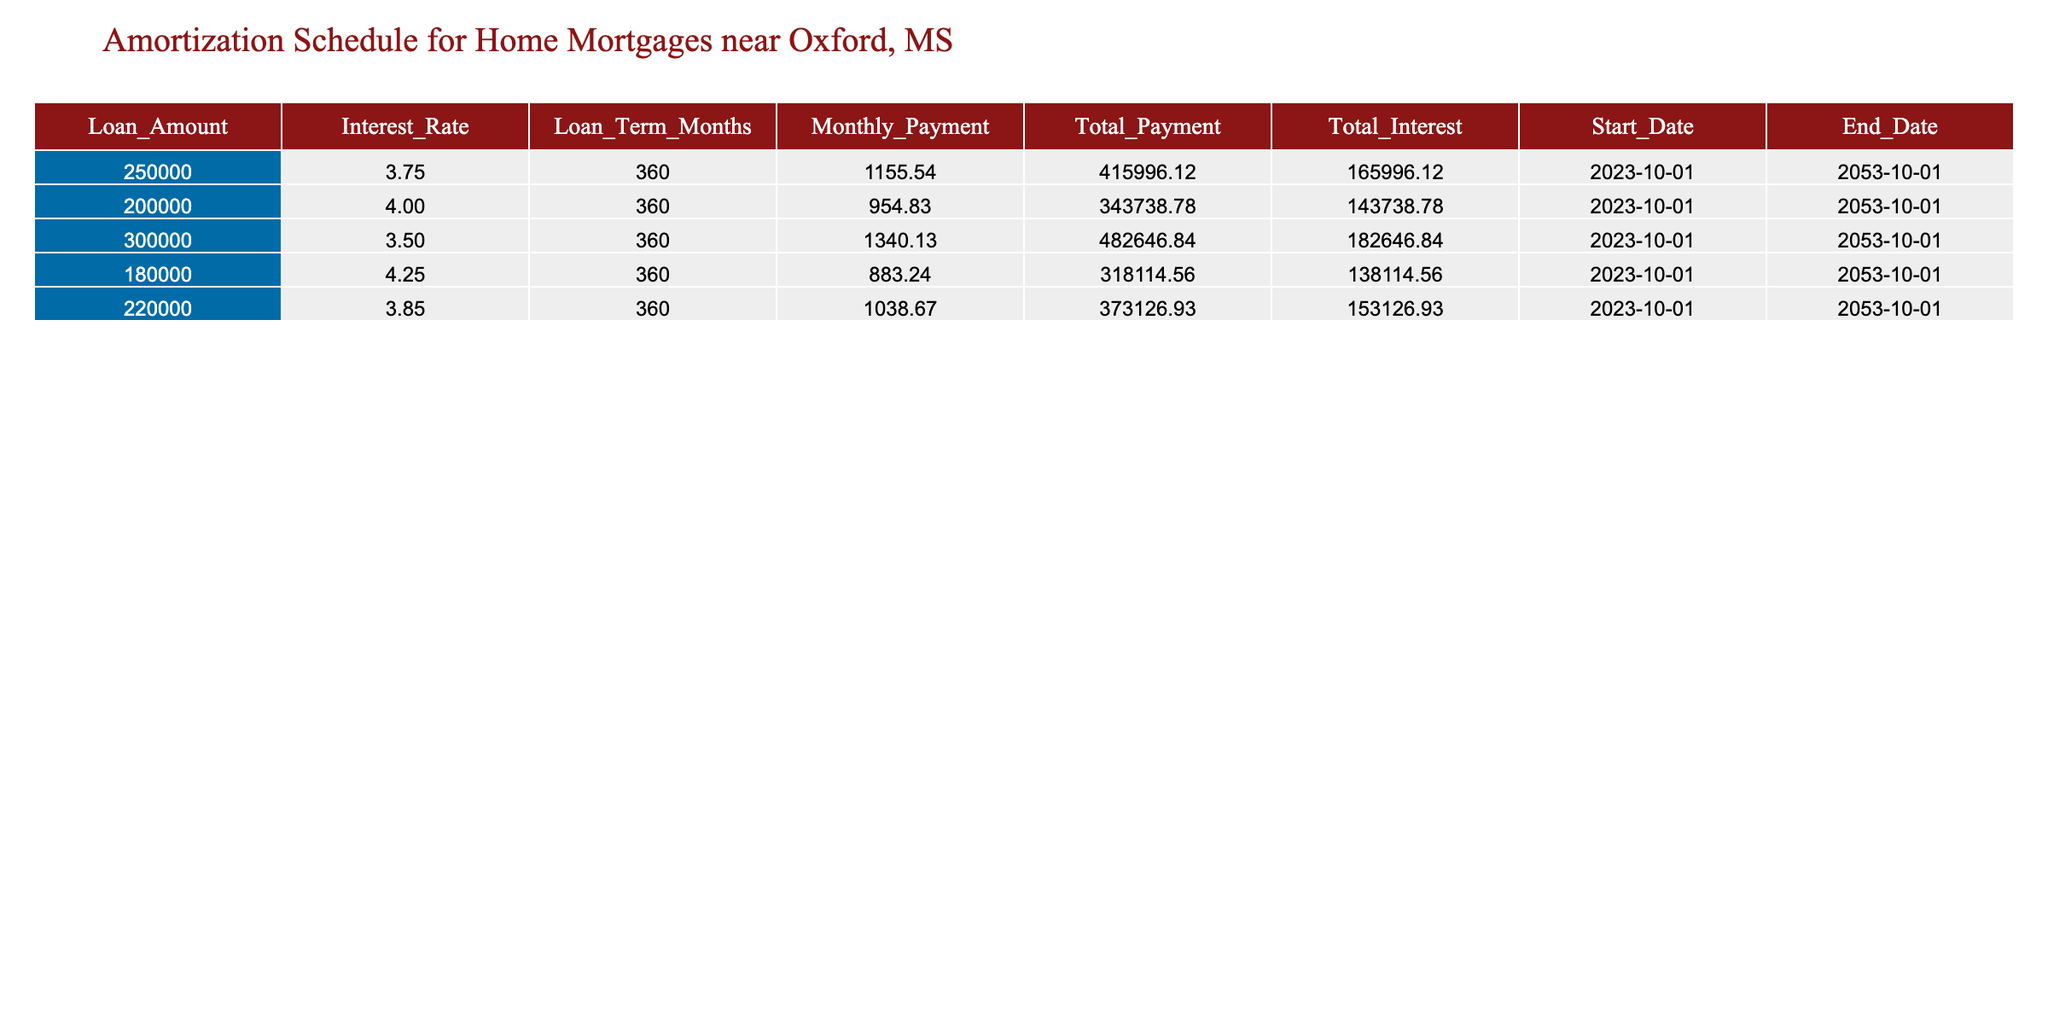What is the monthly payment for a loan amount of $250,000? The table shows that the monthly payment for a loan amount of $250,000 is listed under the "Monthly_Payment" column adjacent to that loan amount. The value is 1155.54.
Answer: 1155.54 How much total interest will be paid on the 300,000 loan? Referring to the table, the "Total_Interest" column next to the $300,000 loan amount indicates the total interest to be paid. This value is 182646.84.
Answer: 182646.84 What is the total payment for a loan of $200,000 at an interest rate of 4.00%? The table identifies the total payment for a loan of $200,000 by looking at the "Total_Payment" column next to the corresponding loan amount and interest rate. The total payment is 343738.78.
Answer: 343738.78 Which loan has the highest total payment? To find the loan with the highest total payment, we need to compare the "Total_Payment" values across all loans. The loans total payments are 415996.12, 343738.78, 482646.84, 318114.56, and 373126.93. The highest total payment is 482646.84 for the $300,000 loan.
Answer: 300000 Is the monthly payment for a loan of $220,000 at 3.85% below $1,000? The monthly payment for the loan of $220,000 is found in the "Monthly_Payment" column. The value retrieved is 1038.67, which is above $1,000. Therefore, the statement is false.
Answer: No What is the average total interest across all five loans? To calculate the average total interest, sum the "Total_Interest" values: 165996.12 + 143738.78 + 182646.84 + 138114.56 + 153126.93 = 783622.23. Then, divide by the number of loans (5). Thus, 783622.23 / 5 = 156724.45.
Answer: 156724.45 Is the monthly payment for the $180,000 loan less than that for a $250,000 loan? The monthly payment for the $180,000 loan is 883.24, while the payment for the $250,000 loan is 1155.54. Since 883.24 is indeed less than 1155.54, the answer is yes.
Answer: Yes Which loan has the shortest duration until the end date, based on the loan term months? By examining the "Loan_Term_Months" for all loans, we see that all loans have the same term of 360 months. Therefore, the duration is equal across all loans.
Answer: None, they all have the same duration 